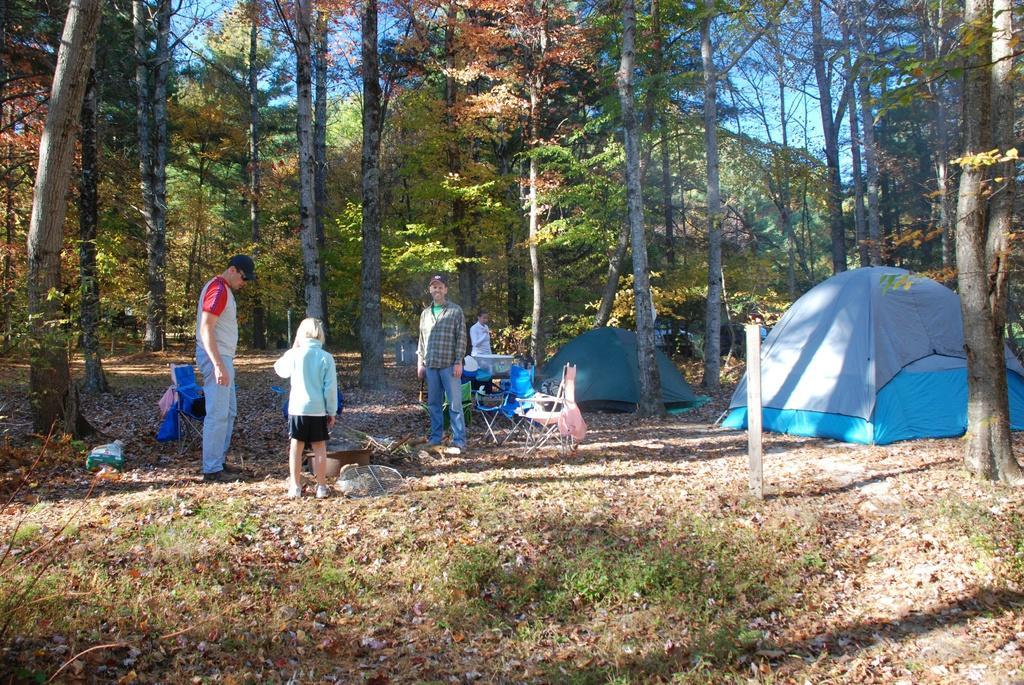In one or two sentences, can you explain what this image depicts? In the image we can see there are many people standing, wearing clothes and shoes, some of them are wearing a cap. This is a tent, grass, pole, trees and a pale blue color sky. We can even see there are chairs. 